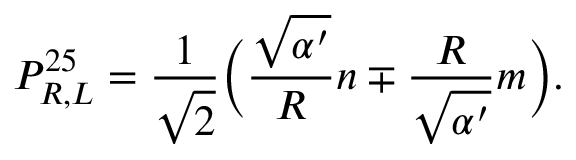<formula> <loc_0><loc_0><loc_500><loc_500>P _ { R , L } ^ { 2 5 } = \frac { 1 } { \sqrt { 2 } } \left ( \frac { \sqrt { \alpha ^ { \prime } } } { R } n \mp \frac { R } { \sqrt { \alpha ^ { \prime } } } m \right ) .</formula> 